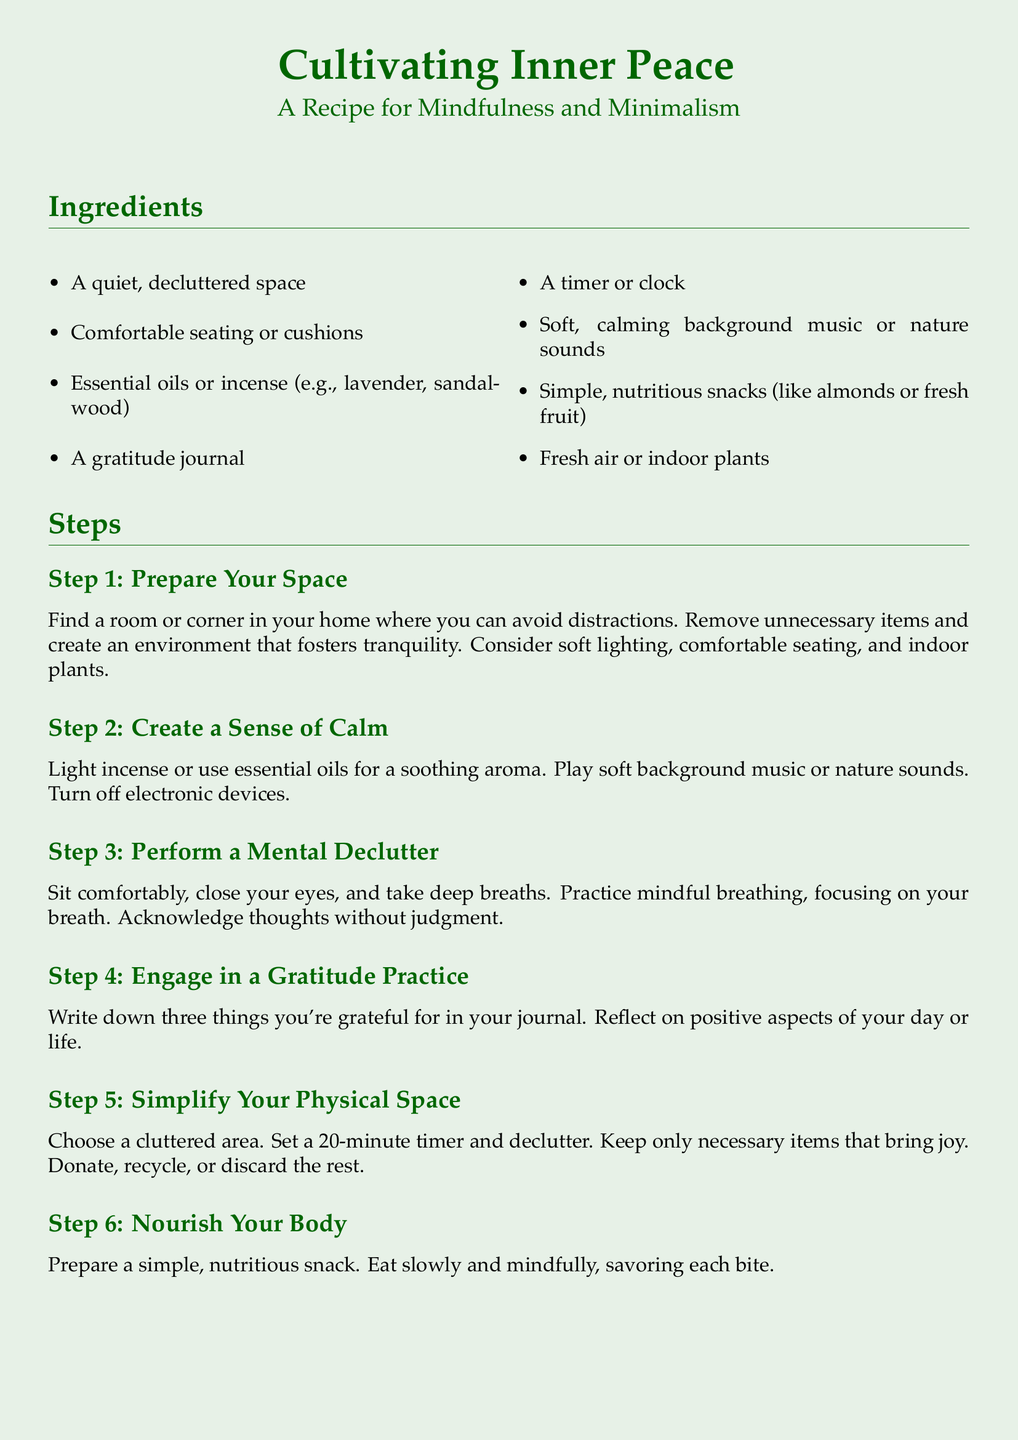What are the essential oils mentioned? The document lists lavender and sandalwood as the essential oils used for creating a calming aroma.
Answer: lavender, sandalwood How many steps are there in the recipe? The document outlines a total of seven steps to follow in the mindfulness and minimalism practice.
Answer: 7 What is the first step in the process? The first step is to prepare your space, which involves creating a tranquil environment by decluttering.
Answer: Prepare Your Space What should be written in the gratitude journal? The document suggests writing down three things you're grateful for as part of the gratitude practice.
Answer: Three things you're grateful for What is the recommended time for decluttering? The document advises setting a 20-minute timer for decluttering a specific area.
Answer: 20 minutes Which sounds are recommended for background? The document recommends using soft background music or nature sounds to create a calming environment.
Answer: Soft background music or nature sounds What is the final reminder stated in the document? The document concludes with the reminder that inner peace is a journey, not a destination.
Answer: Inner peace is a journey, not a destination What type of space is required for this recipe? A quiet, decluttered space is needed to foster tranquility during the mindfulness practice.
Answer: Quiet, decluttered space Which activity is recommended after the decluttering step? After decluttering, the document suggests reflecting on the mindfulness practice and resting in the peaceful environment.
Answer: Reflect and Rest 